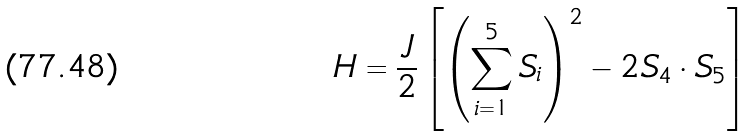Convert formula to latex. <formula><loc_0><loc_0><loc_500><loc_500>H = \frac { J } { 2 } \left [ \left ( \sum _ { i = 1 } ^ { 5 } S _ { i } \right ) ^ { 2 } - 2 S _ { 4 } \cdot S _ { 5 } \right ]</formula> 